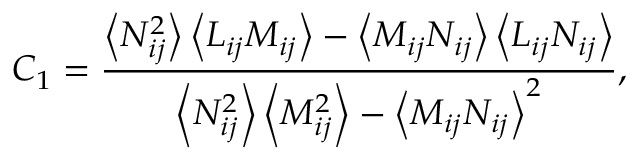Convert formula to latex. <formula><loc_0><loc_0><loc_500><loc_500>C _ { 1 } = \frac { \left \langle N _ { i j } ^ { 2 } \right \rangle \left \langle L _ { i j } M _ { i j } \right \rangle - \left \langle M _ { i j } N _ { i j } \right \rangle \left \langle L _ { i j } N _ { i j } \right \rangle } { \left \langle N _ { i j } ^ { 2 } \right \rangle \left \langle M _ { i j } ^ { 2 } \right \rangle - \left \langle M _ { i j } N _ { i j } \right \rangle ^ { 2 } } ,</formula> 